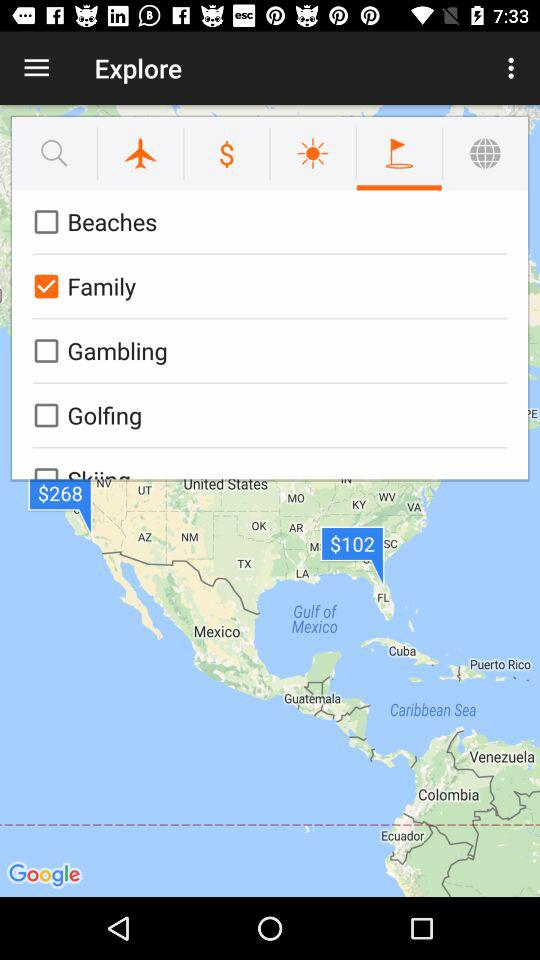How much does the plane cost?
When the provided information is insufficient, respond with <no answer>. <no answer> 